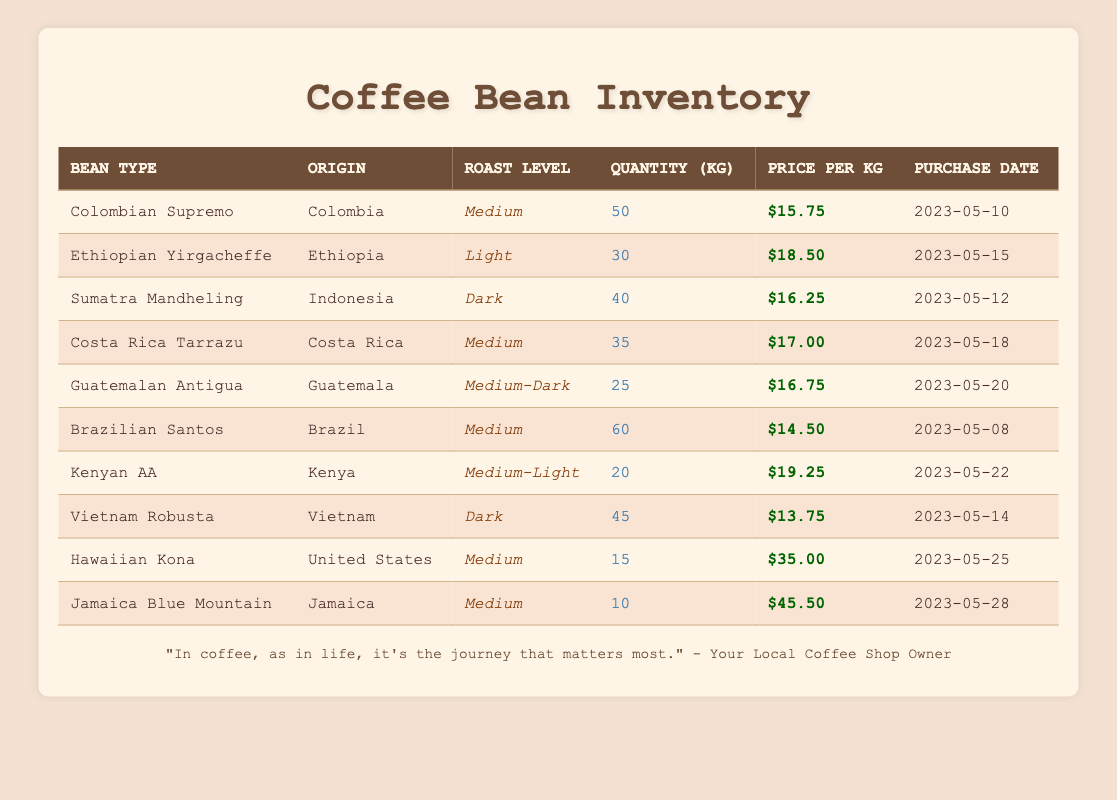What is the total quantity of Colombian Supremo beans in kilograms? The table shows that the quantity of Colombian Supremo beans is listed as 50 kg. Therefore, the total quantity of Colombian Supremo beans is simply the value presented in the quantity column for that bean type.
Answer: 50 kg Which coffee bean has the highest price per kilogram? By evaluating the price per kg for each bean type, the highest value is $45.50, which corresponds to Jamaica Blue Mountain. I looked through the price column to find the maximum value.
Answer: Jamaica Blue Mountain How many kilograms of coffee beans from Brazil do we have? The only coffee bean sourced from Brazil is the Brazilian Santos, which has a quantity of 60 kg. The answer comes from directly checking the quantity listed for Brazilian Santos in the table.
Answer: 60 kg What is the average price per kilogram for all coffee beans in inventory? To calculate the average price, sum all the prices: (15.75 + 18.50 + 16.25 + 17.00 + 16.75 + 14.50 + 19.25 + 13.75 + 35.00 + 45.50) =  16.90; there are 10 beans, so 16.90 / 10 = 16.90. This involves both addition and dividing by the number of different beans.
Answer: $20.12 Does the coffee bean from Vietnam have a greater quantity than that from Guatemala? The quantity of Vietnam Robusta is 45 kg, while the quantity of Guatemalan Antigua is 25 kg. Since 45 kg is greater than 25 kg, the statement is true. I compared the quantities directly in the respective rows of the table.
Answer: Yes What is the quantity difference between the coffee beans from Kenya and Ethiopia? The Kenyan AA coffee has a quantity of 20 kg and the Ethiopian Yirgacheffe has a quantity of 30 kg. The difference is calculated as 30 - 20 = 10 kg since you subtract the smaller quantity from the larger quantity.
Answer: 10 kg Which roast levels are represented for the coffee beans from Colombia and Costa Rica? Colombian Supremo is Medium and Costa Rica Tarrazu is also Medium. By checking the roast level column for beans associated with those countries, I confirm they share the same roast level.
Answer: Medium How many total kilograms of coffee beans listed in the inventory are classified as Dark roast? Sum the quantities for the beans classified as Dark: Sumatra Mandheling has 40 kg and Vietnam Robusta has 45 kg; adding these gives a total of 40 + 45 = 85 kg. This requires identifying those specific beans and adding their quantities together.
Answer: 85 kg Is there more coffee of Medium roast level than any other roast level in the inventory? The Medium roast level beans are Colombian Supremo (50 kg), Costa Rica Tarrazu (35 kg), and Brazilian Santos (60 kg), which total 50 + 35 + 60 = 145 kg. Other roast levels have less total quantity when summed up, so this is indeed more. I compared totals across all roast levels.
Answer: Yes 